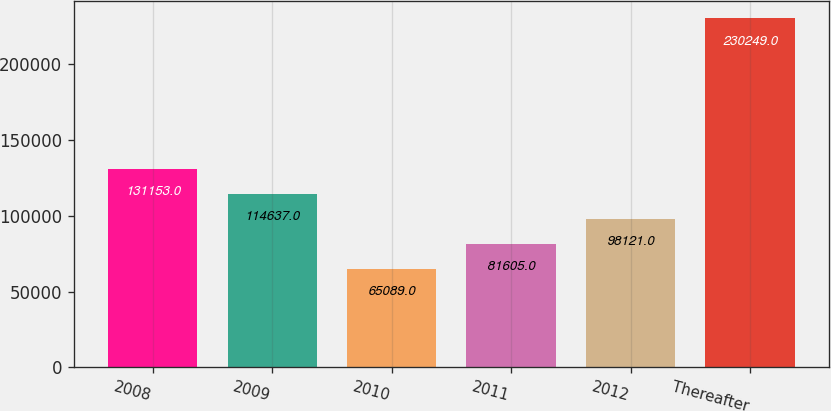Convert chart. <chart><loc_0><loc_0><loc_500><loc_500><bar_chart><fcel>2008<fcel>2009<fcel>2010<fcel>2011<fcel>2012<fcel>Thereafter<nl><fcel>131153<fcel>114637<fcel>65089<fcel>81605<fcel>98121<fcel>230249<nl></chart> 